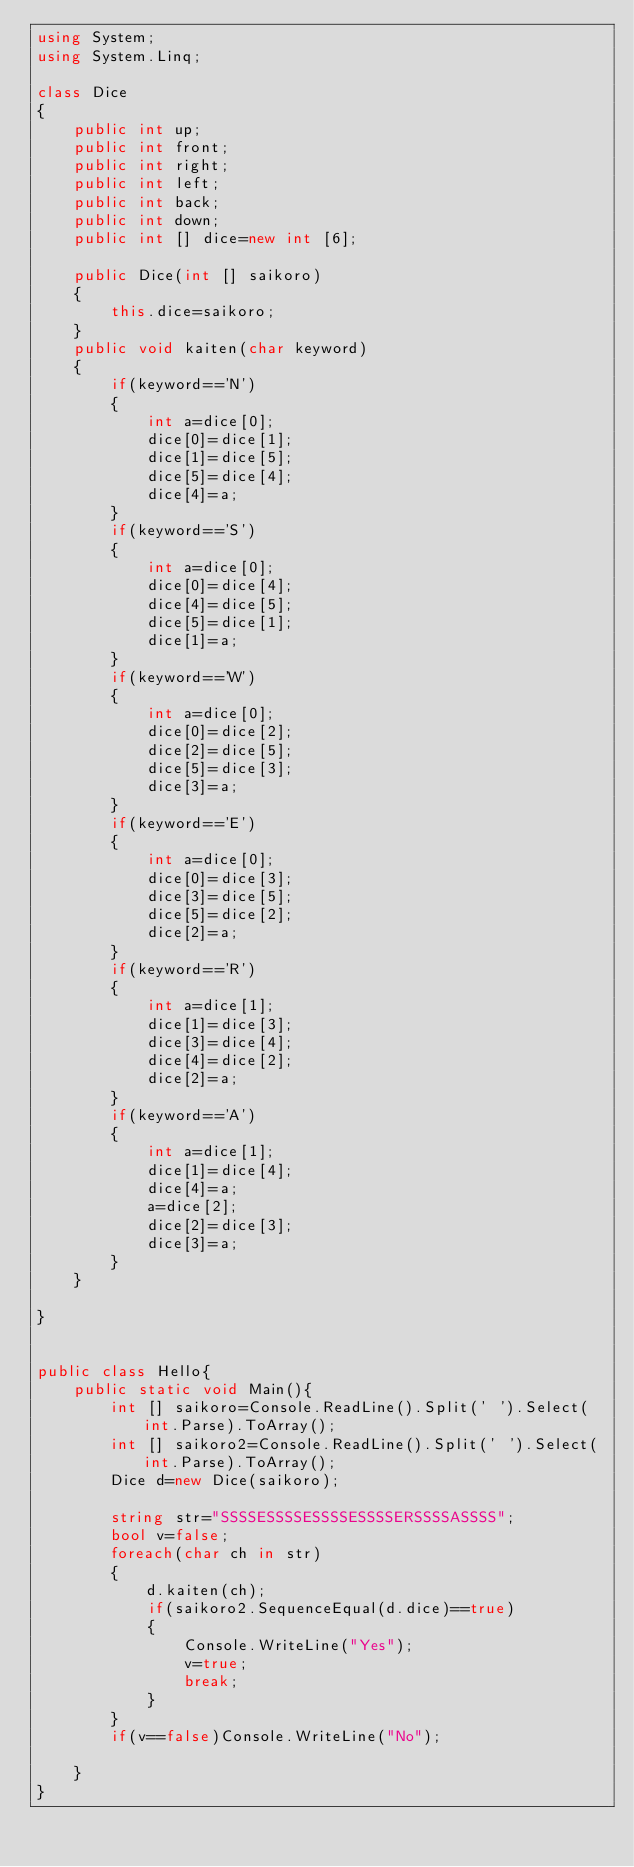Convert code to text. <code><loc_0><loc_0><loc_500><loc_500><_C#_>using System;
using System.Linq;

class Dice
{
    public int up;
    public int front;
    public int right;
    public int left;
    public int back;
    public int down;
    public int [] dice=new int [6];
    
    public Dice(int [] saikoro)
    {
        this.dice=saikoro;
    }
    public void kaiten(char keyword)
    {
        if(keyword=='N')
        {
            int a=dice[0];
            dice[0]=dice[1];
            dice[1]=dice[5];
            dice[5]=dice[4];
            dice[4]=a;
        }
        if(keyword=='S')
        {
            int a=dice[0];
            dice[0]=dice[4];
            dice[4]=dice[5];
            dice[5]=dice[1];
            dice[1]=a;
        }
        if(keyword=='W')
        {
            int a=dice[0];
            dice[0]=dice[2];
            dice[2]=dice[5];
            dice[5]=dice[3];
            dice[3]=a;
        }
        if(keyword=='E')
        {
            int a=dice[0];
            dice[0]=dice[3];
            dice[3]=dice[5];
            dice[5]=dice[2];
            dice[2]=a;
        }
        if(keyword=='R')
        {
            int a=dice[1];
            dice[1]=dice[3];
            dice[3]=dice[4];
            dice[4]=dice[2];
            dice[2]=a;
        }
        if(keyword=='A')
        {
            int a=dice[1];
            dice[1]=dice[4];
            dice[4]=a;
            a=dice[2];
            dice[2]=dice[3];
            dice[3]=a;
        }
    }
    
}


public class Hello{
    public static void Main(){
        int [] saikoro=Console.ReadLine().Split(' ').Select(int.Parse).ToArray();
        int [] saikoro2=Console.ReadLine().Split(' ').Select(int.Parse).ToArray();
        Dice d=new Dice(saikoro);
        
        string str="SSSSESSSSESSSSESSSSERSSSSASSSS";
        bool v=false;
        foreach(char ch in str)
        {
            d.kaiten(ch);
            if(saikoro2.SequenceEqual(d.dice)==true)
            {
                Console.WriteLine("Yes");
                v=true;
                break;
            }
        }
        if(v==false)Console.WriteLine("No");
        
    }
}
</code> 